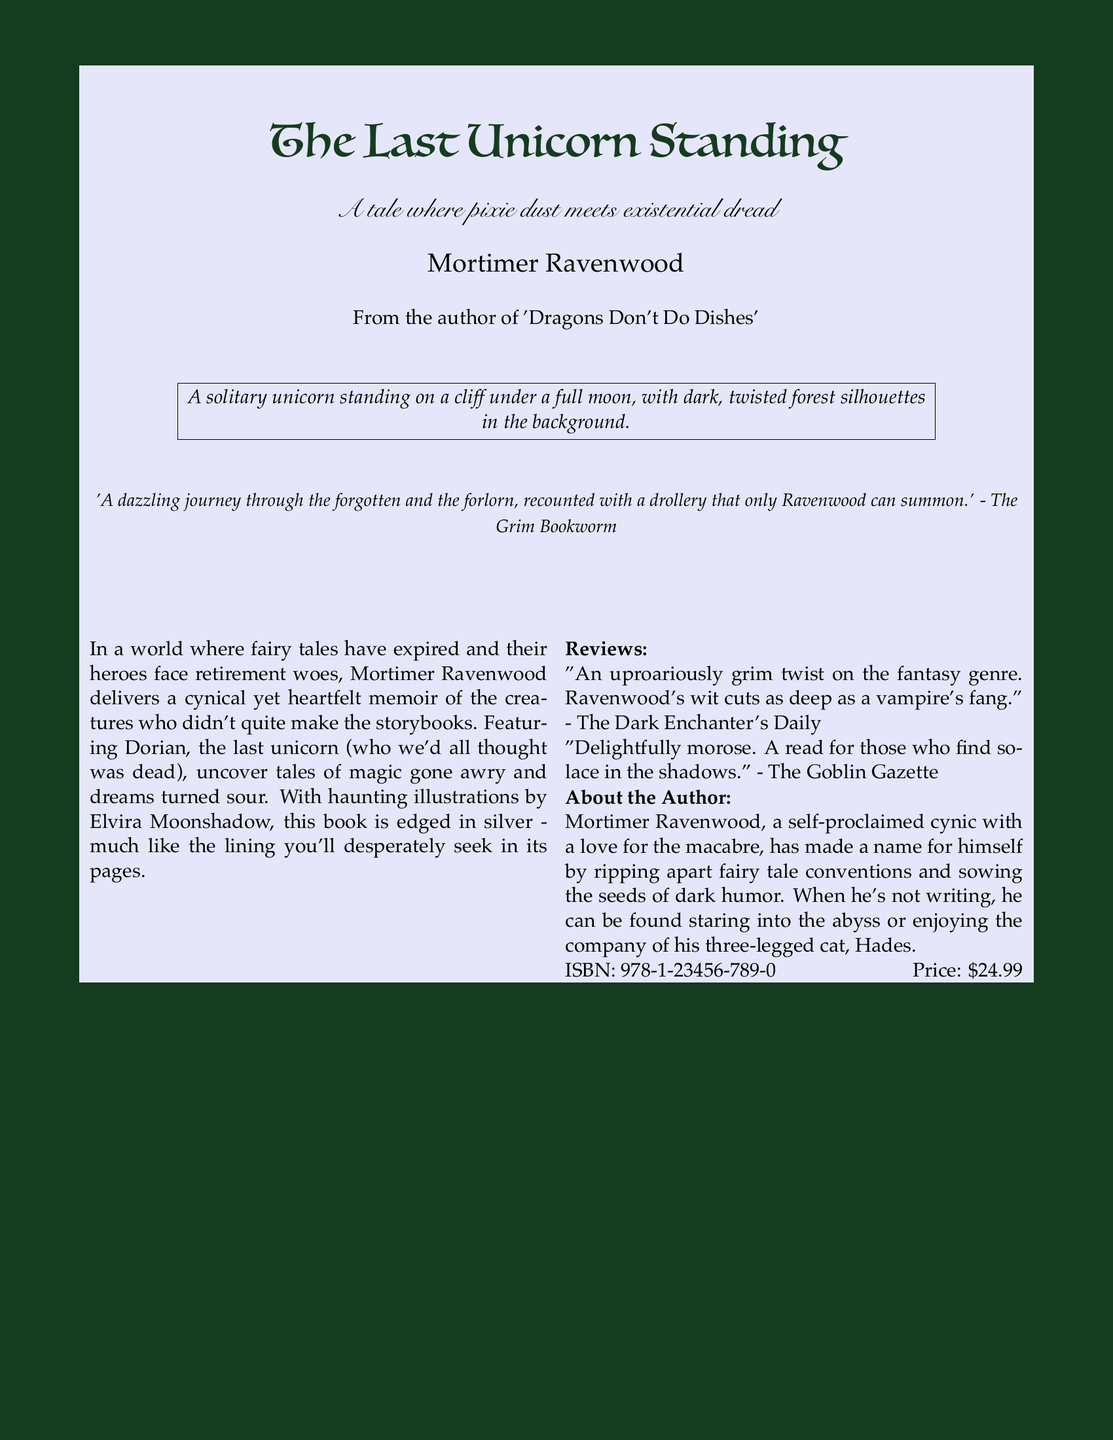What is the title of the book? The title is prominently displayed at the top of the document in a large font style.
Answer: The Last Unicorn Standing Who is the author of the book? The author's name is listed right below the title in a smaller font.
Answer: Mortimer Ravenwood What is the tagline of the book? The tagline provides a brief insight into the theme of the book.
Answer: A tale where pixie dust meets existential dread What is the price of the book? The price is mentioned at the bottom of the document.
Answer: $24.99 What is the ISBN? The ISBN is a unique identifier found at the bottom of the document.
Answer: 978-1-23456-789-0 What kind of illustrations are featured in the book? The document mentions the illustrator and the style of the illustrations.
Answer: Haunting illustrations What does the quote by The Grim Bookworm say? The quote highlights the book's tone and style, providing an external perspective on its content.
Answer: A dazzling journey through the forgotten and the forlorn, recounted with a drollery that only Ravenwood can summon Who is Elvira Moonshadow? Elvira Moonshadow is indicated as the illustrator of the book in the text.
Answer: Illustrator What animal does the author have? The author’s pet is mentioned in the "About the Author" section.
Answer: Three-legged cat What genre does this book challenge? The premise indicates that this book provides a twist on traditional narratives.
Answer: Fantasy genre 